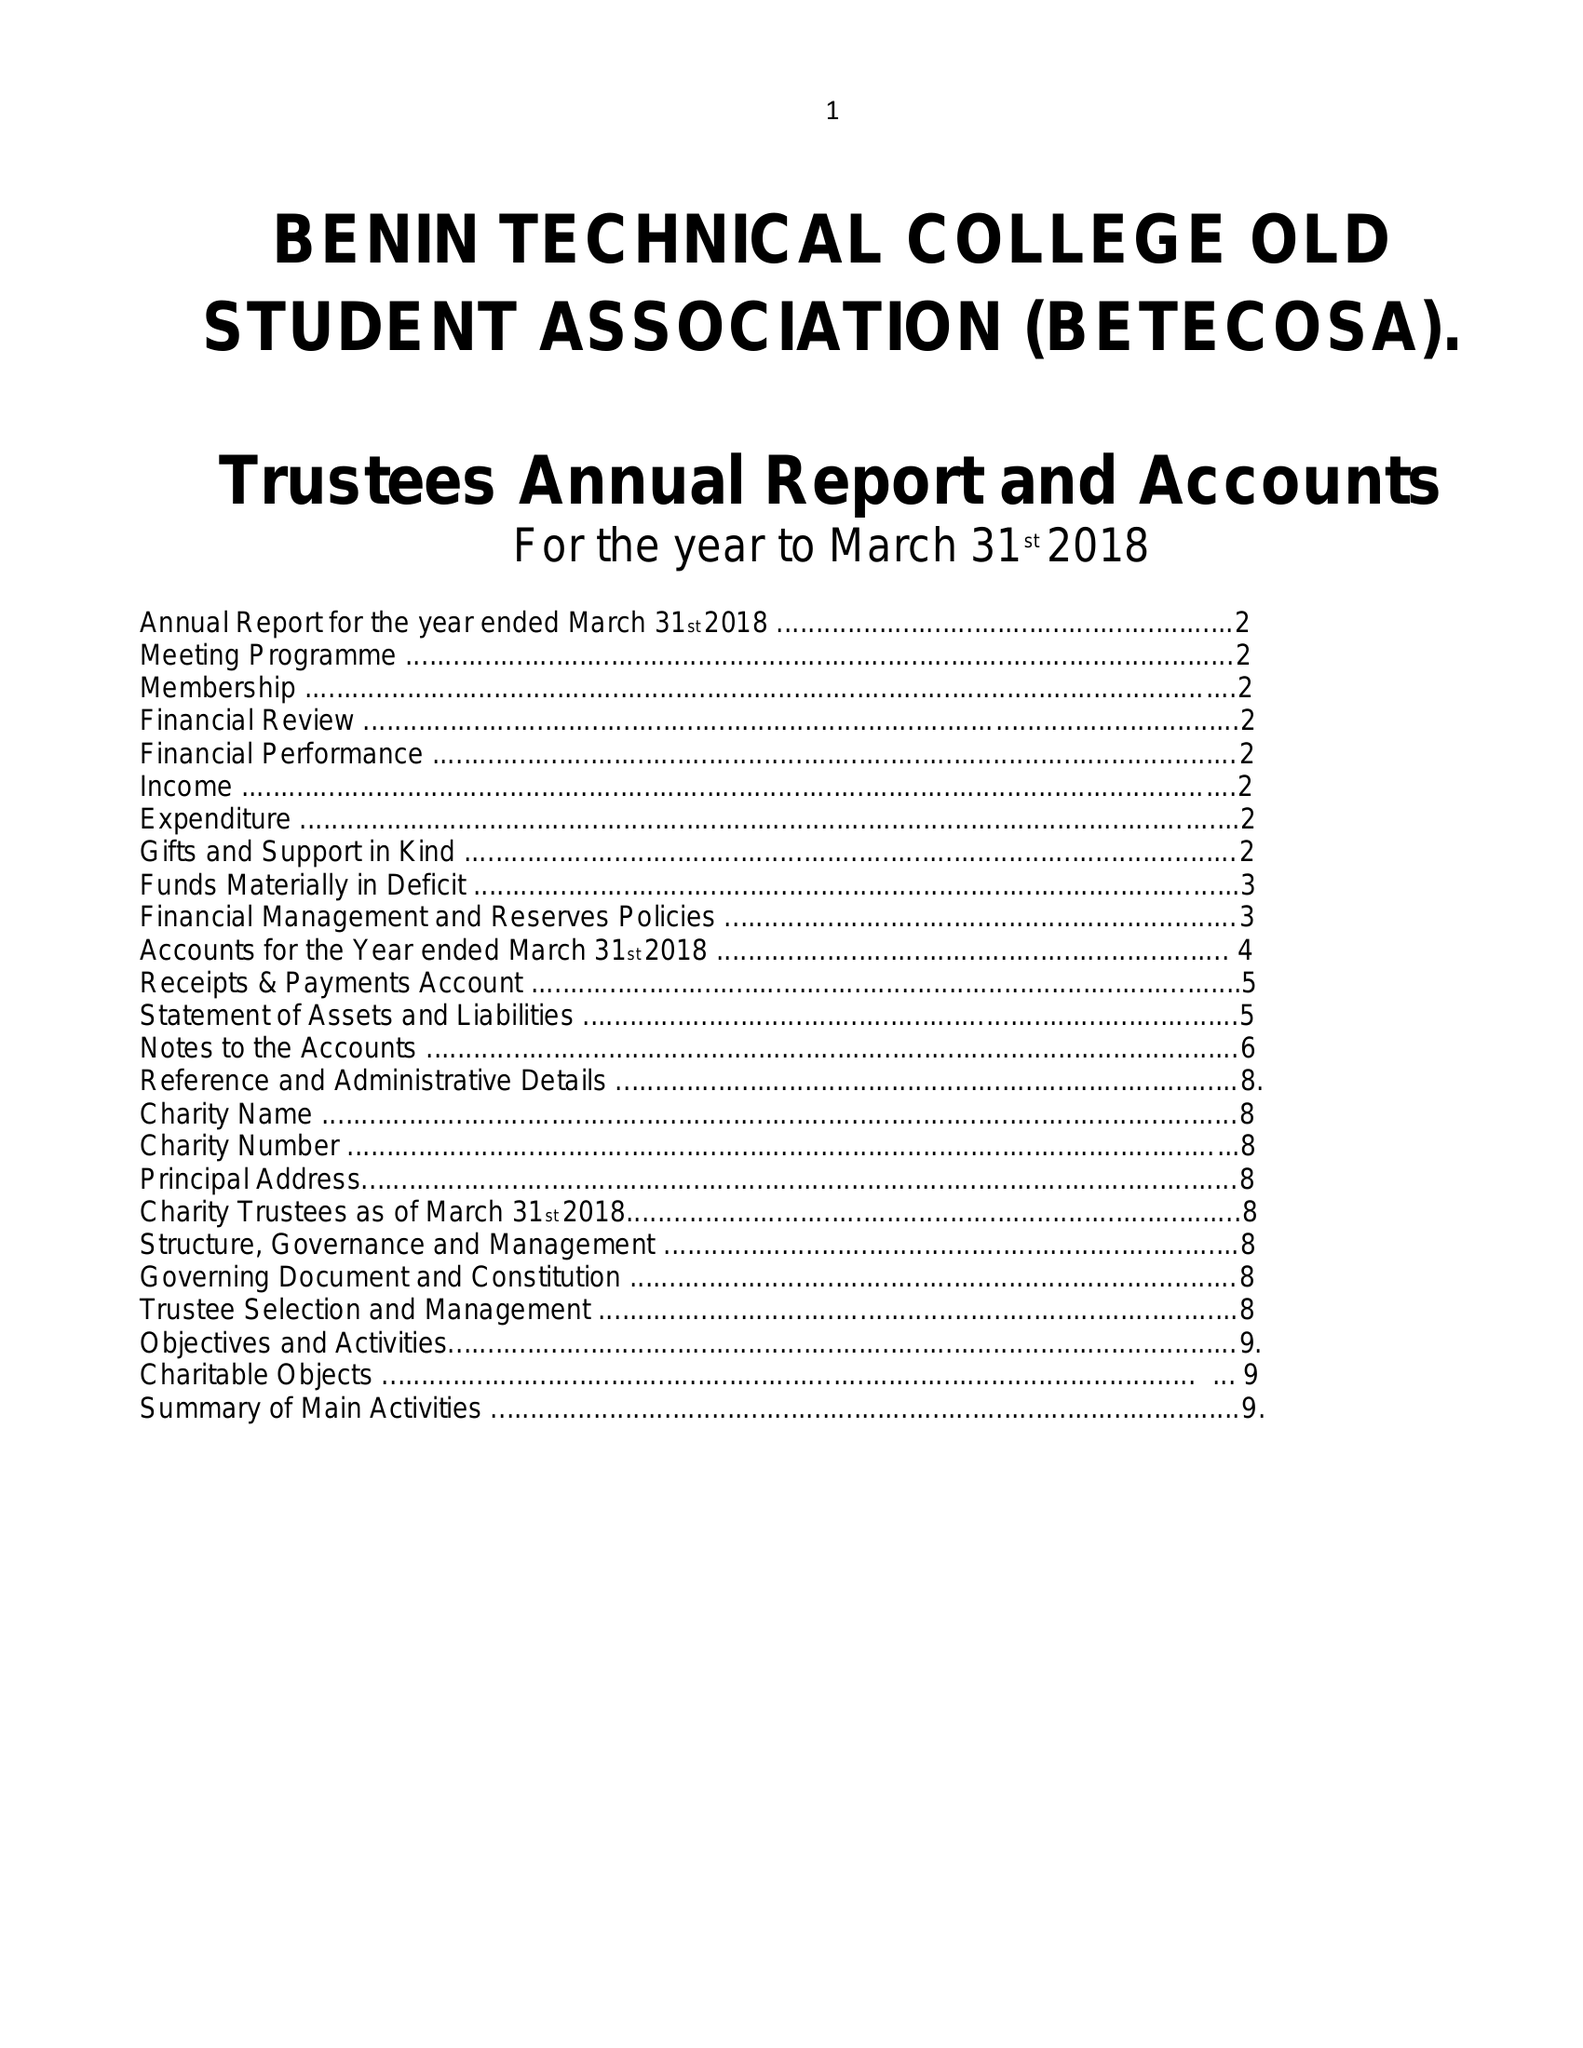What is the value for the address__postcode?
Answer the question using a single word or phrase. SE6 4PH 